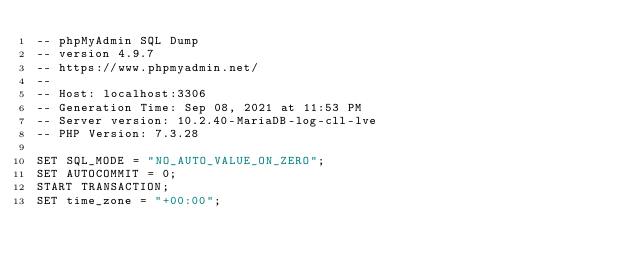<code> <loc_0><loc_0><loc_500><loc_500><_SQL_>-- phpMyAdmin SQL Dump
-- version 4.9.7
-- https://www.phpmyadmin.net/
--
-- Host: localhost:3306
-- Generation Time: Sep 08, 2021 at 11:53 PM
-- Server version: 10.2.40-MariaDB-log-cll-lve
-- PHP Version: 7.3.28

SET SQL_MODE = "NO_AUTO_VALUE_ON_ZERO";
SET AUTOCOMMIT = 0;
START TRANSACTION;
SET time_zone = "+00:00";

</code> 